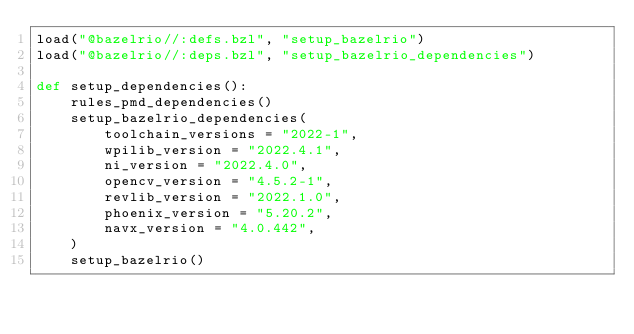<code> <loc_0><loc_0><loc_500><loc_500><_Python_>load("@bazelrio//:defs.bzl", "setup_bazelrio")
load("@bazelrio//:deps.bzl", "setup_bazelrio_dependencies")

def setup_dependencies():
    rules_pmd_dependencies()
    setup_bazelrio_dependencies(
        toolchain_versions = "2022-1",
        wpilib_version = "2022.4.1",
        ni_version = "2022.4.0",
        opencv_version = "4.5.2-1",
        revlib_version = "2022.1.0",
        phoenix_version = "5.20.2",
        navx_version = "4.0.442",
    )
    setup_bazelrio()
</code> 